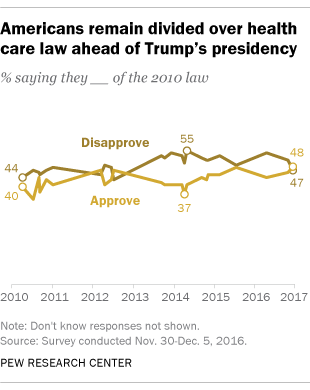Specify some key components in this picture. The starting value of light brown in the graph is 40. The difference between light and brown graph 1 was in 2017. 